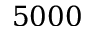Convert formula to latex. <formula><loc_0><loc_0><loc_500><loc_500>5 0 0 0</formula> 